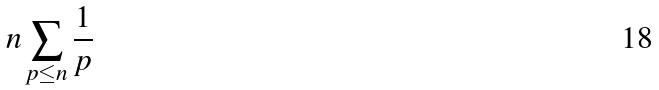Convert formula to latex. <formula><loc_0><loc_0><loc_500><loc_500>n \sum _ { p \leq n } \frac { 1 } { p }</formula> 